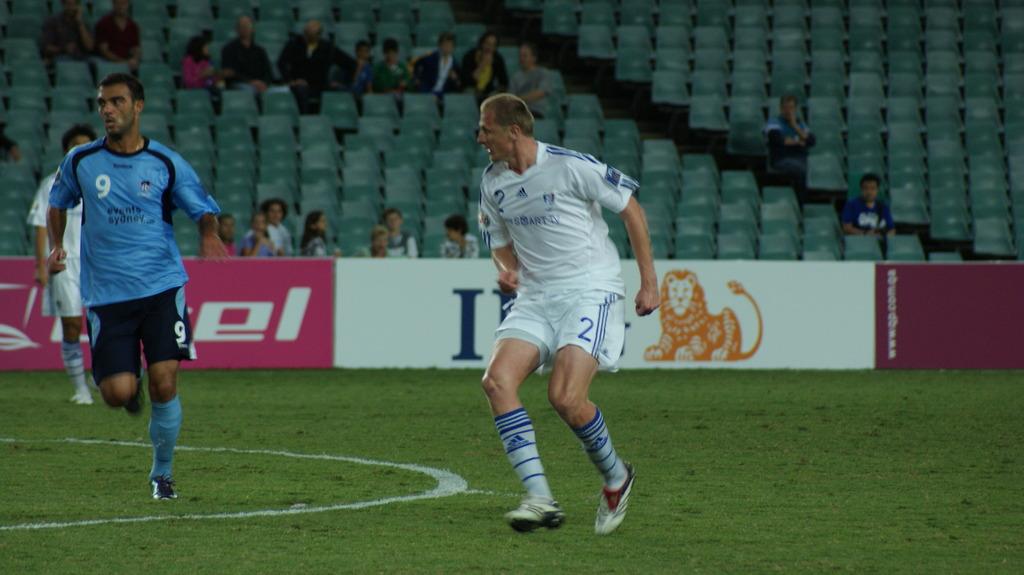What is the number of the player in blue?
Your answer should be compact. 9. What is the number of the player in white?
Provide a short and direct response. 2. 